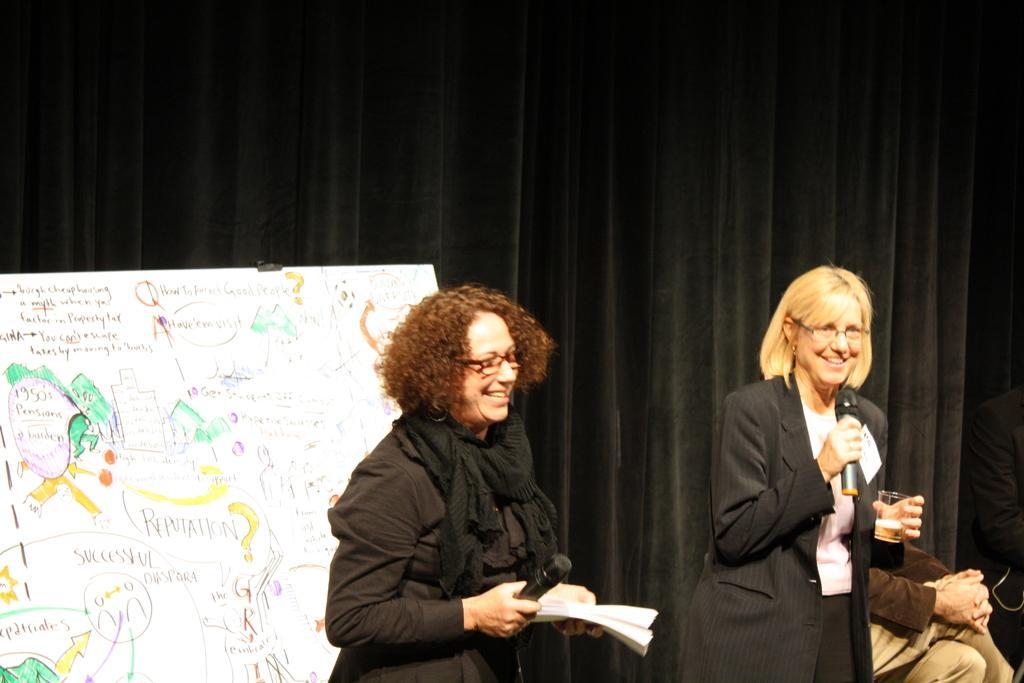In one or two sentences, can you explain what this image depicts? In this image there are two ladies standing on the stage holding microphones in hands where one of them is holding glass with water and other one holding papers, behind them there is a white board and some note. 